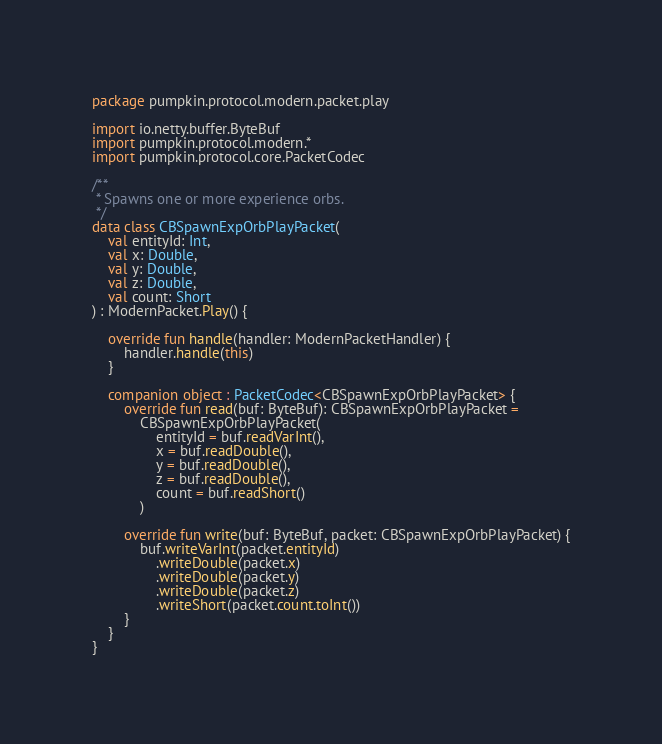<code> <loc_0><loc_0><loc_500><loc_500><_Kotlin_>package pumpkin.protocol.modern.packet.play

import io.netty.buffer.ByteBuf
import pumpkin.protocol.modern.*
import pumpkin.protocol.core.PacketCodec

/**
 * Spawns one or more experience orbs.
 */
data class CBSpawnExpOrbPlayPacket(
    val entityId: Int,
    val x: Double,
    val y: Double,
    val z: Double,
    val count: Short
) : ModernPacket.Play() {

    override fun handle(handler: ModernPacketHandler) {
        handler.handle(this)
    }

    companion object : PacketCodec<CBSpawnExpOrbPlayPacket> {
        override fun read(buf: ByteBuf): CBSpawnExpOrbPlayPacket =
            CBSpawnExpOrbPlayPacket(
                entityId = buf.readVarInt(),
                x = buf.readDouble(),
                y = buf.readDouble(),
                z = buf.readDouble(),
                count = buf.readShort()
            )

        override fun write(buf: ByteBuf, packet: CBSpawnExpOrbPlayPacket) {
            buf.writeVarInt(packet.entityId)
                .writeDouble(packet.x)
                .writeDouble(packet.y)
                .writeDouble(packet.z)
                .writeShort(packet.count.toInt())
        }
    }
}</code> 